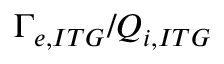Convert formula to latex. <formula><loc_0><loc_0><loc_500><loc_500>\Gamma _ { e , I T G } / Q _ { i , I T G }</formula> 